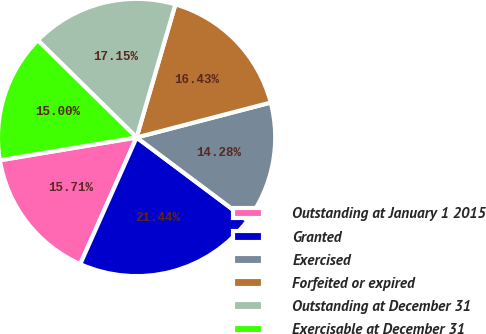<chart> <loc_0><loc_0><loc_500><loc_500><pie_chart><fcel>Outstanding at January 1 2015<fcel>Granted<fcel>Exercised<fcel>Forfeited or expired<fcel>Outstanding at December 31<fcel>Exercisable at December 31<nl><fcel>15.71%<fcel>21.44%<fcel>14.28%<fcel>16.43%<fcel>17.15%<fcel>15.0%<nl></chart> 